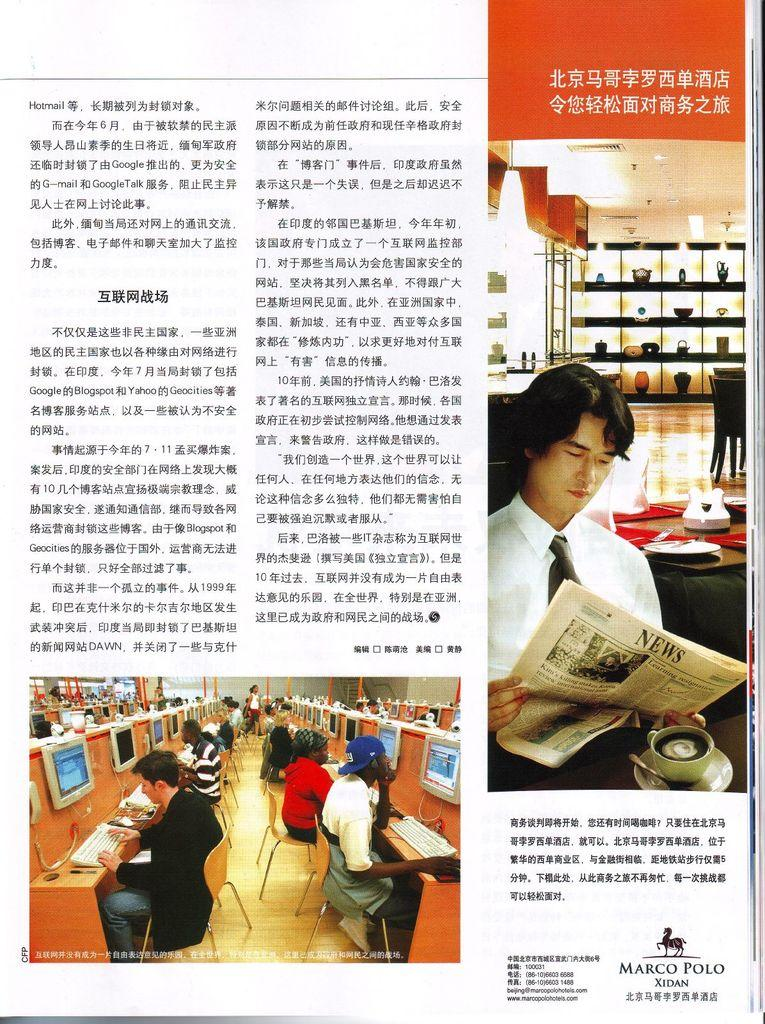<image>
Provide a brief description of the given image. A page in a magazine that shows an ad for Marco Polo Hotels in China. 